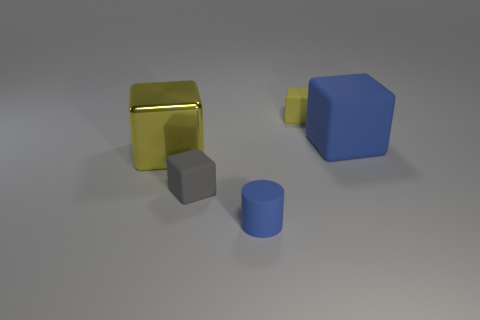How many other things are there of the same color as the large matte cube?
Offer a terse response. 1. Is the shape of the gray matte thing the same as the blue matte thing behind the small gray block?
Provide a succinct answer. Yes. Are there fewer small yellow matte cubes to the left of the small cylinder than tiny matte cubes that are to the right of the gray thing?
Offer a terse response. Yes. There is a large yellow object that is the same shape as the big blue matte object; what material is it?
Provide a succinct answer. Metal. Is there anything else that is made of the same material as the big yellow thing?
Offer a terse response. No. Is the small rubber cylinder the same color as the large matte object?
Give a very brief answer. Yes. There is a yellow object that is the same material as the cylinder; what is its shape?
Ensure brevity in your answer.  Cube. How many other yellow matte objects have the same shape as the yellow matte object?
Your answer should be compact. 0. What shape is the yellow matte thing right of the shiny cube in front of the tiny yellow block?
Keep it short and to the point. Cube. There is a blue rubber thing in front of the gray block; is it the same size as the yellow rubber block?
Give a very brief answer. Yes. 